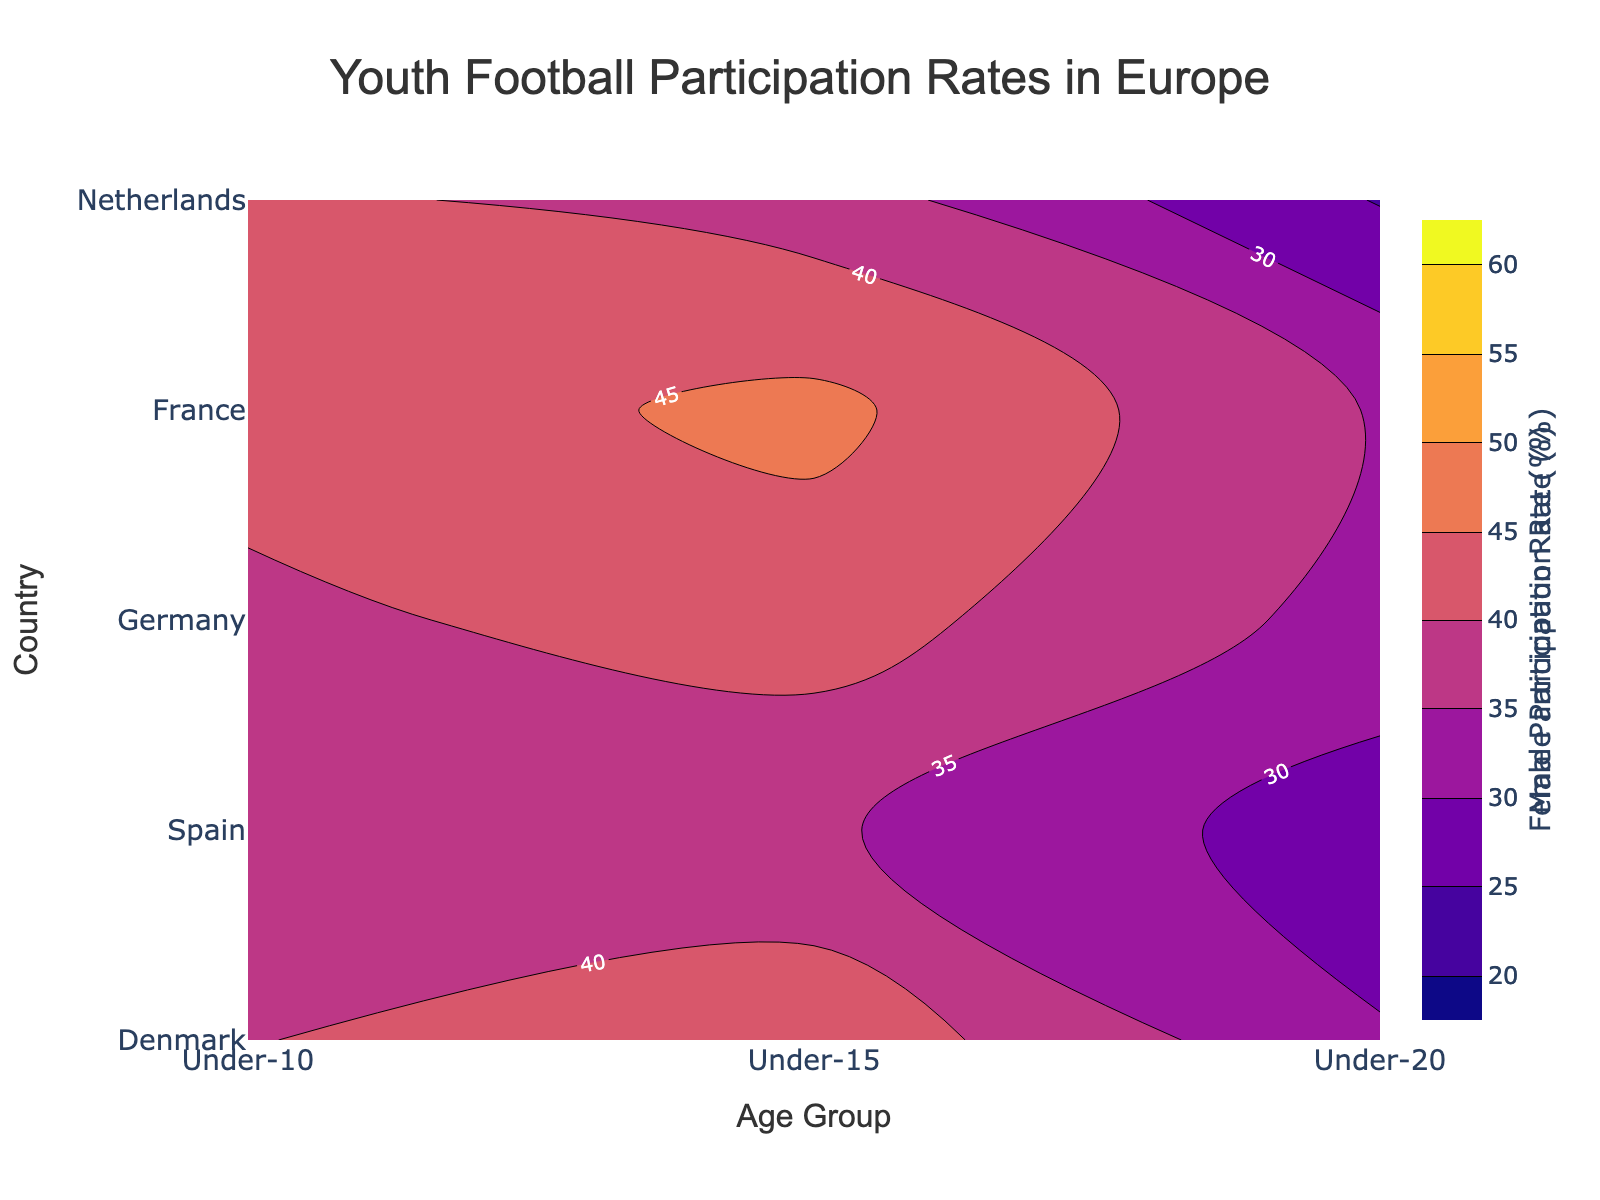What's the title of the figure? The title of the figure is displayed at the top, centered and readable. It summarizes the overall content of the figure.
Answer: Youth Football Participation Rates in Europe Which age group has the highest participation rate for males in the Netherlands? Look for the contour areas representing the Netherlands and the age-specific contours for males. The highest value for males in the Netherlands is found at the peak of the contours.
Answer: Under-15 What is the participation rate for females under-20 in Spain? Search for the contour plot specifically for females and then locate the contour line for Spain under the age group "Under-20". The number on the contour line gives the participation rate.
Answer: 24.7% In which country do males under-15 have the highest participation rate? Compare the contour lines for the "Under-15" age group across the various countries. The country with the highest contour line value represents the highest participation rate.
Answer: Netherlands What is the difference in the participation rate of females under-15 between Denmark and France? Identify the contour lines for females under the "Under-15" age group for both Denmark and France. Calculate the difference between these values.
Answer: 43.5% - 35.7% = 7.8% Which gender has a higher participation rate across most age groups in Germany? Compare the contour plots for males and females across all age groups in Germany, focusing on which contours generally present higher values.
Answer: Males How does the participation rate for Danish males under-15 compare to the rate for Spanish males under-15? Locate the contour lines for Danish males under "Under-15" and compare it with the contour line for Spanish males under the same age group. Determine which one is higher.
Answer: Denmark: 52.1%, Spain: 49.3%; Denmark is higher In which age group do French females have the lowest participation rate? Look at the contour plot for females in France and identify the age group with the lowest value on the contour lines.
Answer: Under-20 What is the average participation rate for males under-10 across the five countries? Identify the contour values for males under-10 across the five countries and calculate the average of these values.
Answer: (45.2 + 47.5 + 46.8 + 44.9 + 50.6) / 5 = 46.0 Does female participation in football decrease more sharply with age in Spain or Denmark? Examine the contour plots for females in both Spain and Denmark across the age groups and observe the slope or gradient changes to infer the rate of decrease.
Answer: Spain 